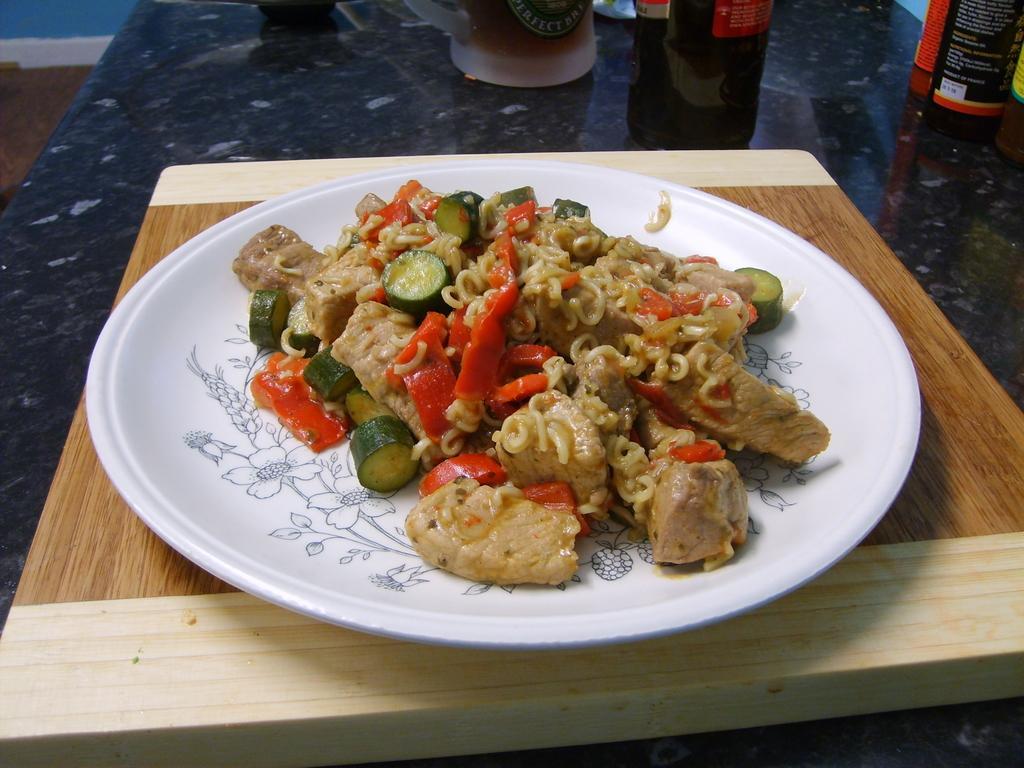Please provide a concise description of this image. In this image we can see food in a plate which is on a wooden plank. In the background we can see bottles which are truncated on a platform. 